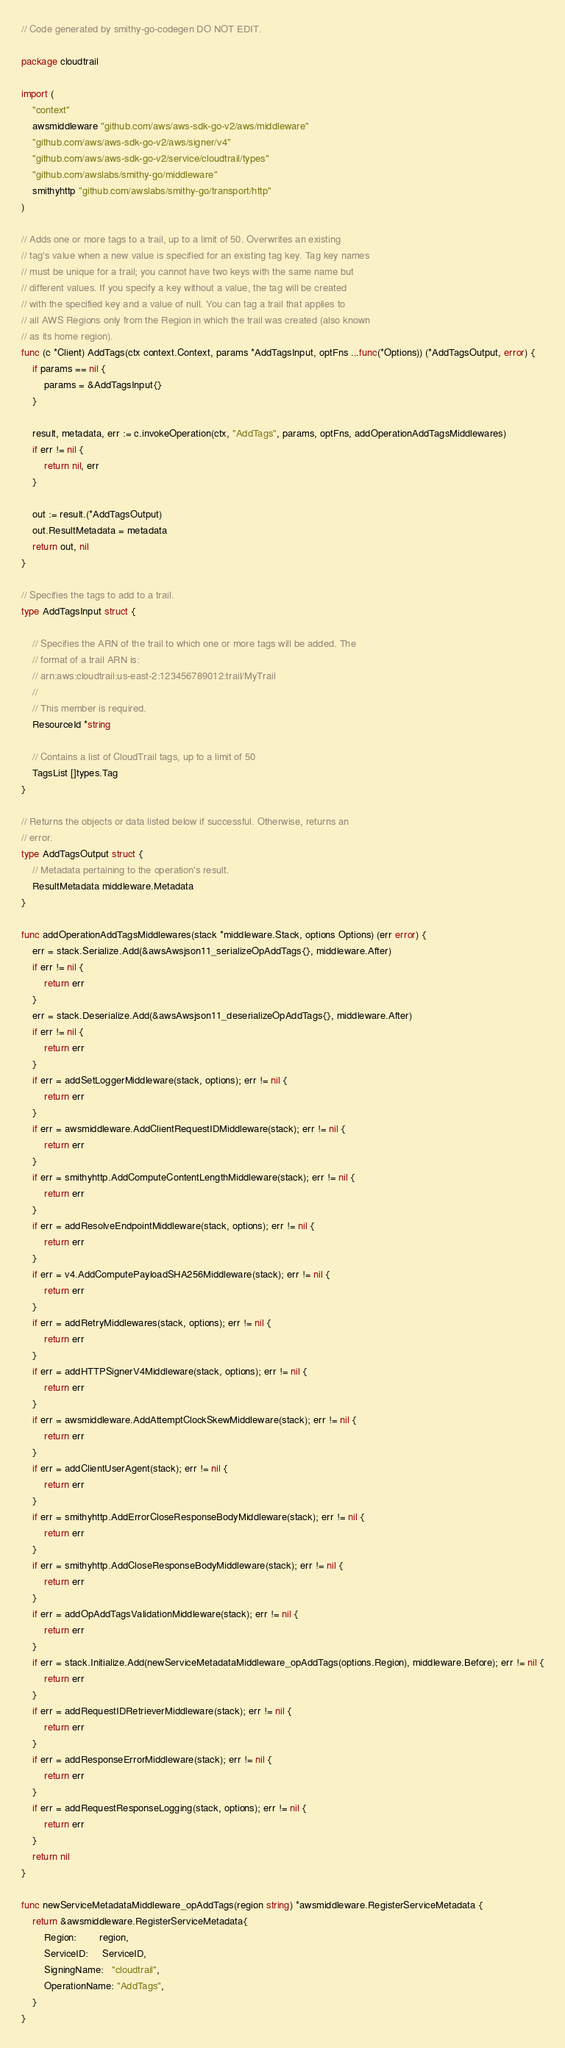Convert code to text. <code><loc_0><loc_0><loc_500><loc_500><_Go_>// Code generated by smithy-go-codegen DO NOT EDIT.

package cloudtrail

import (
	"context"
	awsmiddleware "github.com/aws/aws-sdk-go-v2/aws/middleware"
	"github.com/aws/aws-sdk-go-v2/aws/signer/v4"
	"github.com/aws/aws-sdk-go-v2/service/cloudtrail/types"
	"github.com/awslabs/smithy-go/middleware"
	smithyhttp "github.com/awslabs/smithy-go/transport/http"
)

// Adds one or more tags to a trail, up to a limit of 50. Overwrites an existing
// tag's value when a new value is specified for an existing tag key. Tag key names
// must be unique for a trail; you cannot have two keys with the same name but
// different values. If you specify a key without a value, the tag will be created
// with the specified key and a value of null. You can tag a trail that applies to
// all AWS Regions only from the Region in which the trail was created (also known
// as its home region).
func (c *Client) AddTags(ctx context.Context, params *AddTagsInput, optFns ...func(*Options)) (*AddTagsOutput, error) {
	if params == nil {
		params = &AddTagsInput{}
	}

	result, metadata, err := c.invokeOperation(ctx, "AddTags", params, optFns, addOperationAddTagsMiddlewares)
	if err != nil {
		return nil, err
	}

	out := result.(*AddTagsOutput)
	out.ResultMetadata = metadata
	return out, nil
}

// Specifies the tags to add to a trail.
type AddTagsInput struct {

	// Specifies the ARN of the trail to which one or more tags will be added. The
	// format of a trail ARN is:
	// arn:aws:cloudtrail:us-east-2:123456789012:trail/MyTrail
	//
	// This member is required.
	ResourceId *string

	// Contains a list of CloudTrail tags, up to a limit of 50
	TagsList []types.Tag
}

// Returns the objects or data listed below if successful. Otherwise, returns an
// error.
type AddTagsOutput struct {
	// Metadata pertaining to the operation's result.
	ResultMetadata middleware.Metadata
}

func addOperationAddTagsMiddlewares(stack *middleware.Stack, options Options) (err error) {
	err = stack.Serialize.Add(&awsAwsjson11_serializeOpAddTags{}, middleware.After)
	if err != nil {
		return err
	}
	err = stack.Deserialize.Add(&awsAwsjson11_deserializeOpAddTags{}, middleware.After)
	if err != nil {
		return err
	}
	if err = addSetLoggerMiddleware(stack, options); err != nil {
		return err
	}
	if err = awsmiddleware.AddClientRequestIDMiddleware(stack); err != nil {
		return err
	}
	if err = smithyhttp.AddComputeContentLengthMiddleware(stack); err != nil {
		return err
	}
	if err = addResolveEndpointMiddleware(stack, options); err != nil {
		return err
	}
	if err = v4.AddComputePayloadSHA256Middleware(stack); err != nil {
		return err
	}
	if err = addRetryMiddlewares(stack, options); err != nil {
		return err
	}
	if err = addHTTPSignerV4Middleware(stack, options); err != nil {
		return err
	}
	if err = awsmiddleware.AddAttemptClockSkewMiddleware(stack); err != nil {
		return err
	}
	if err = addClientUserAgent(stack); err != nil {
		return err
	}
	if err = smithyhttp.AddErrorCloseResponseBodyMiddleware(stack); err != nil {
		return err
	}
	if err = smithyhttp.AddCloseResponseBodyMiddleware(stack); err != nil {
		return err
	}
	if err = addOpAddTagsValidationMiddleware(stack); err != nil {
		return err
	}
	if err = stack.Initialize.Add(newServiceMetadataMiddleware_opAddTags(options.Region), middleware.Before); err != nil {
		return err
	}
	if err = addRequestIDRetrieverMiddleware(stack); err != nil {
		return err
	}
	if err = addResponseErrorMiddleware(stack); err != nil {
		return err
	}
	if err = addRequestResponseLogging(stack, options); err != nil {
		return err
	}
	return nil
}

func newServiceMetadataMiddleware_opAddTags(region string) *awsmiddleware.RegisterServiceMetadata {
	return &awsmiddleware.RegisterServiceMetadata{
		Region:        region,
		ServiceID:     ServiceID,
		SigningName:   "cloudtrail",
		OperationName: "AddTags",
	}
}
</code> 